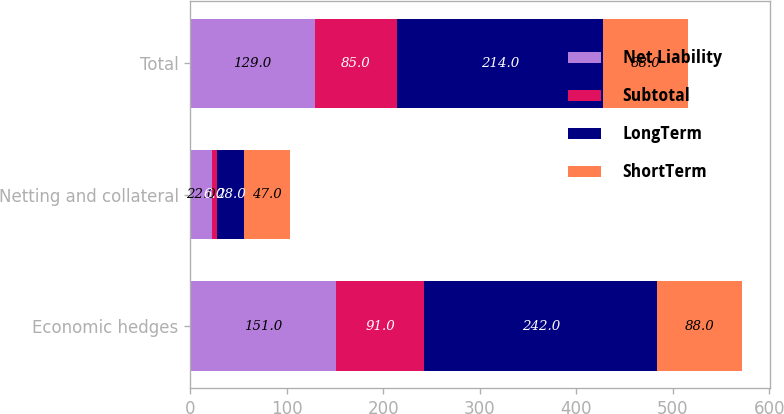Convert chart. <chart><loc_0><loc_0><loc_500><loc_500><stacked_bar_chart><ecel><fcel>Economic hedges<fcel>Netting and collateral<fcel>Total<nl><fcel>Net Liability<fcel>151<fcel>22<fcel>129<nl><fcel>Subtotal<fcel>91<fcel>6<fcel>85<nl><fcel>LongTerm<fcel>242<fcel>28<fcel>214<nl><fcel>ShortTerm<fcel>88<fcel>47<fcel>88<nl></chart> 